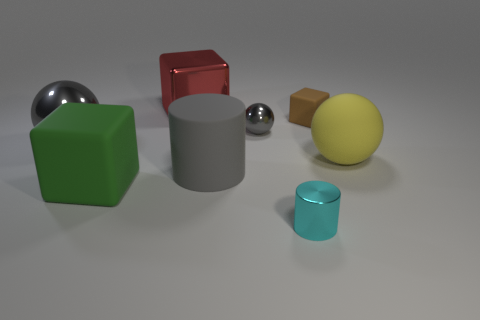Do the big gray ball in front of the tiny gray shiny object and the big object that is on the right side of the small metallic cylinder have the same material?
Provide a short and direct response. No. How many large gray metallic things are there?
Provide a short and direct response. 1. What number of small gray objects have the same shape as the red metallic object?
Your answer should be very brief. 0. Is the shape of the large yellow thing the same as the tiny cyan object?
Keep it short and to the point. No. The brown object is what size?
Offer a terse response. Small. What number of gray metallic balls have the same size as the green object?
Offer a very short reply. 1. Does the gray thing behind the large gray ball have the same size as the cube that is on the left side of the red thing?
Your answer should be compact. No. There is a gray thing that is in front of the big yellow matte thing; what shape is it?
Ensure brevity in your answer.  Cylinder. The large gray object that is to the right of the big shiny thing that is behind the brown thing is made of what material?
Make the answer very short. Rubber. Are there any rubber balls that have the same color as the tiny rubber thing?
Your answer should be compact. No. 